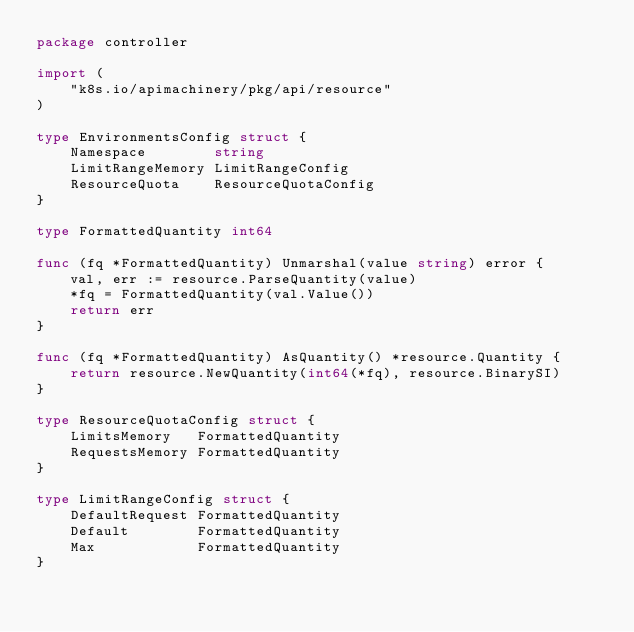Convert code to text. <code><loc_0><loc_0><loc_500><loc_500><_Go_>package controller

import (
	"k8s.io/apimachinery/pkg/api/resource"
)

type EnvironmentsConfig struct {
	Namespace        string
	LimitRangeMemory LimitRangeConfig
	ResourceQuota    ResourceQuotaConfig
}

type FormattedQuantity int64

func (fq *FormattedQuantity) Unmarshal(value string) error {
	val, err := resource.ParseQuantity(value)
	*fq = FormattedQuantity(val.Value())
	return err
}

func (fq *FormattedQuantity) AsQuantity() *resource.Quantity {
	return resource.NewQuantity(int64(*fq), resource.BinarySI)
}

type ResourceQuotaConfig struct {
	LimitsMemory   FormattedQuantity
	RequestsMemory FormattedQuantity
}

type LimitRangeConfig struct {
	DefaultRequest FormattedQuantity
	Default        FormattedQuantity
	Max            FormattedQuantity
}
</code> 